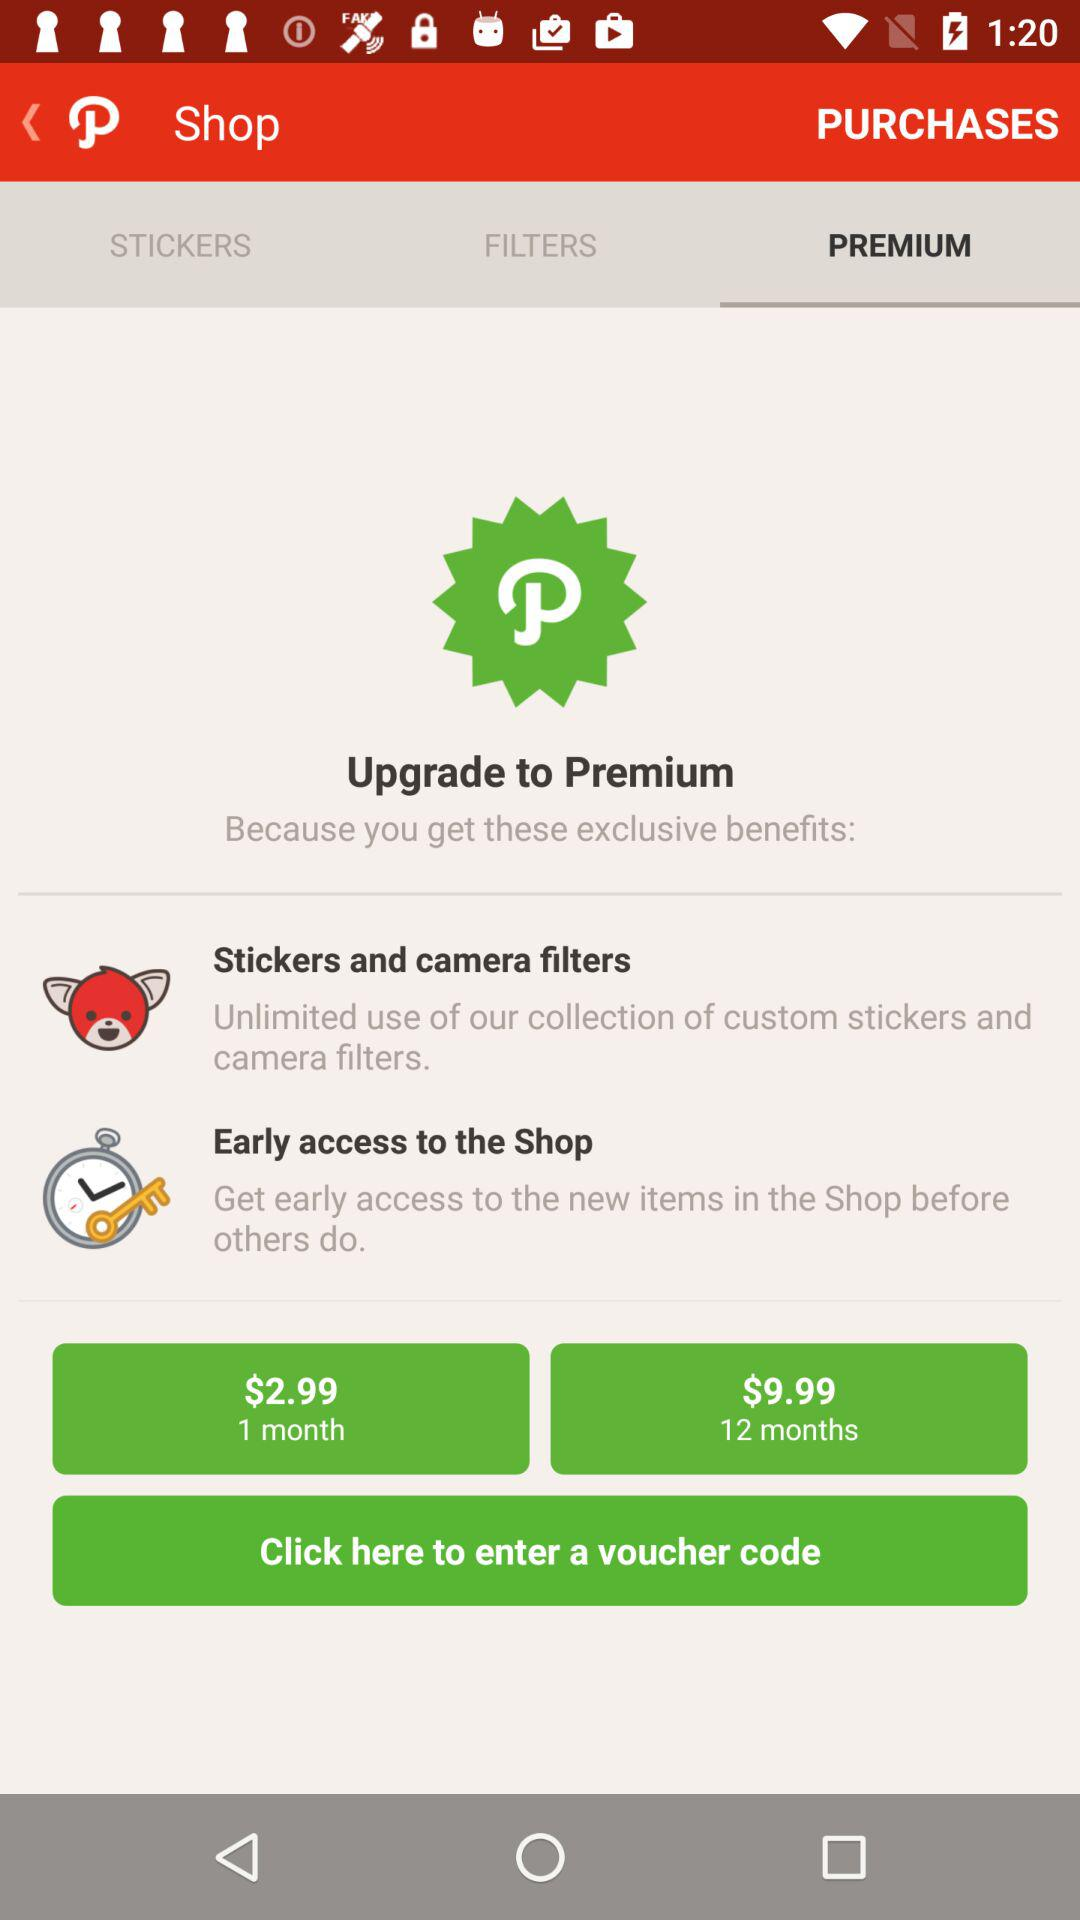What is the price for 1 month? The price for 1 month is $2.99. 